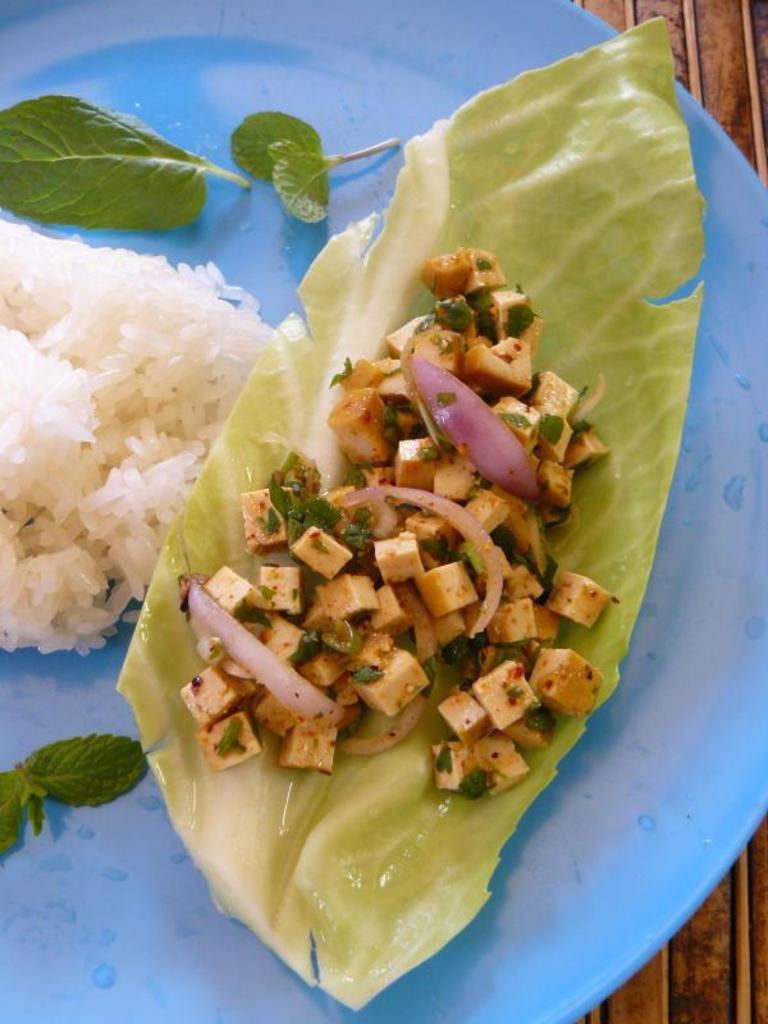In one or two sentences, can you explain what this image depicts? In this picture we can see rice and some other food in the blue color plate. 